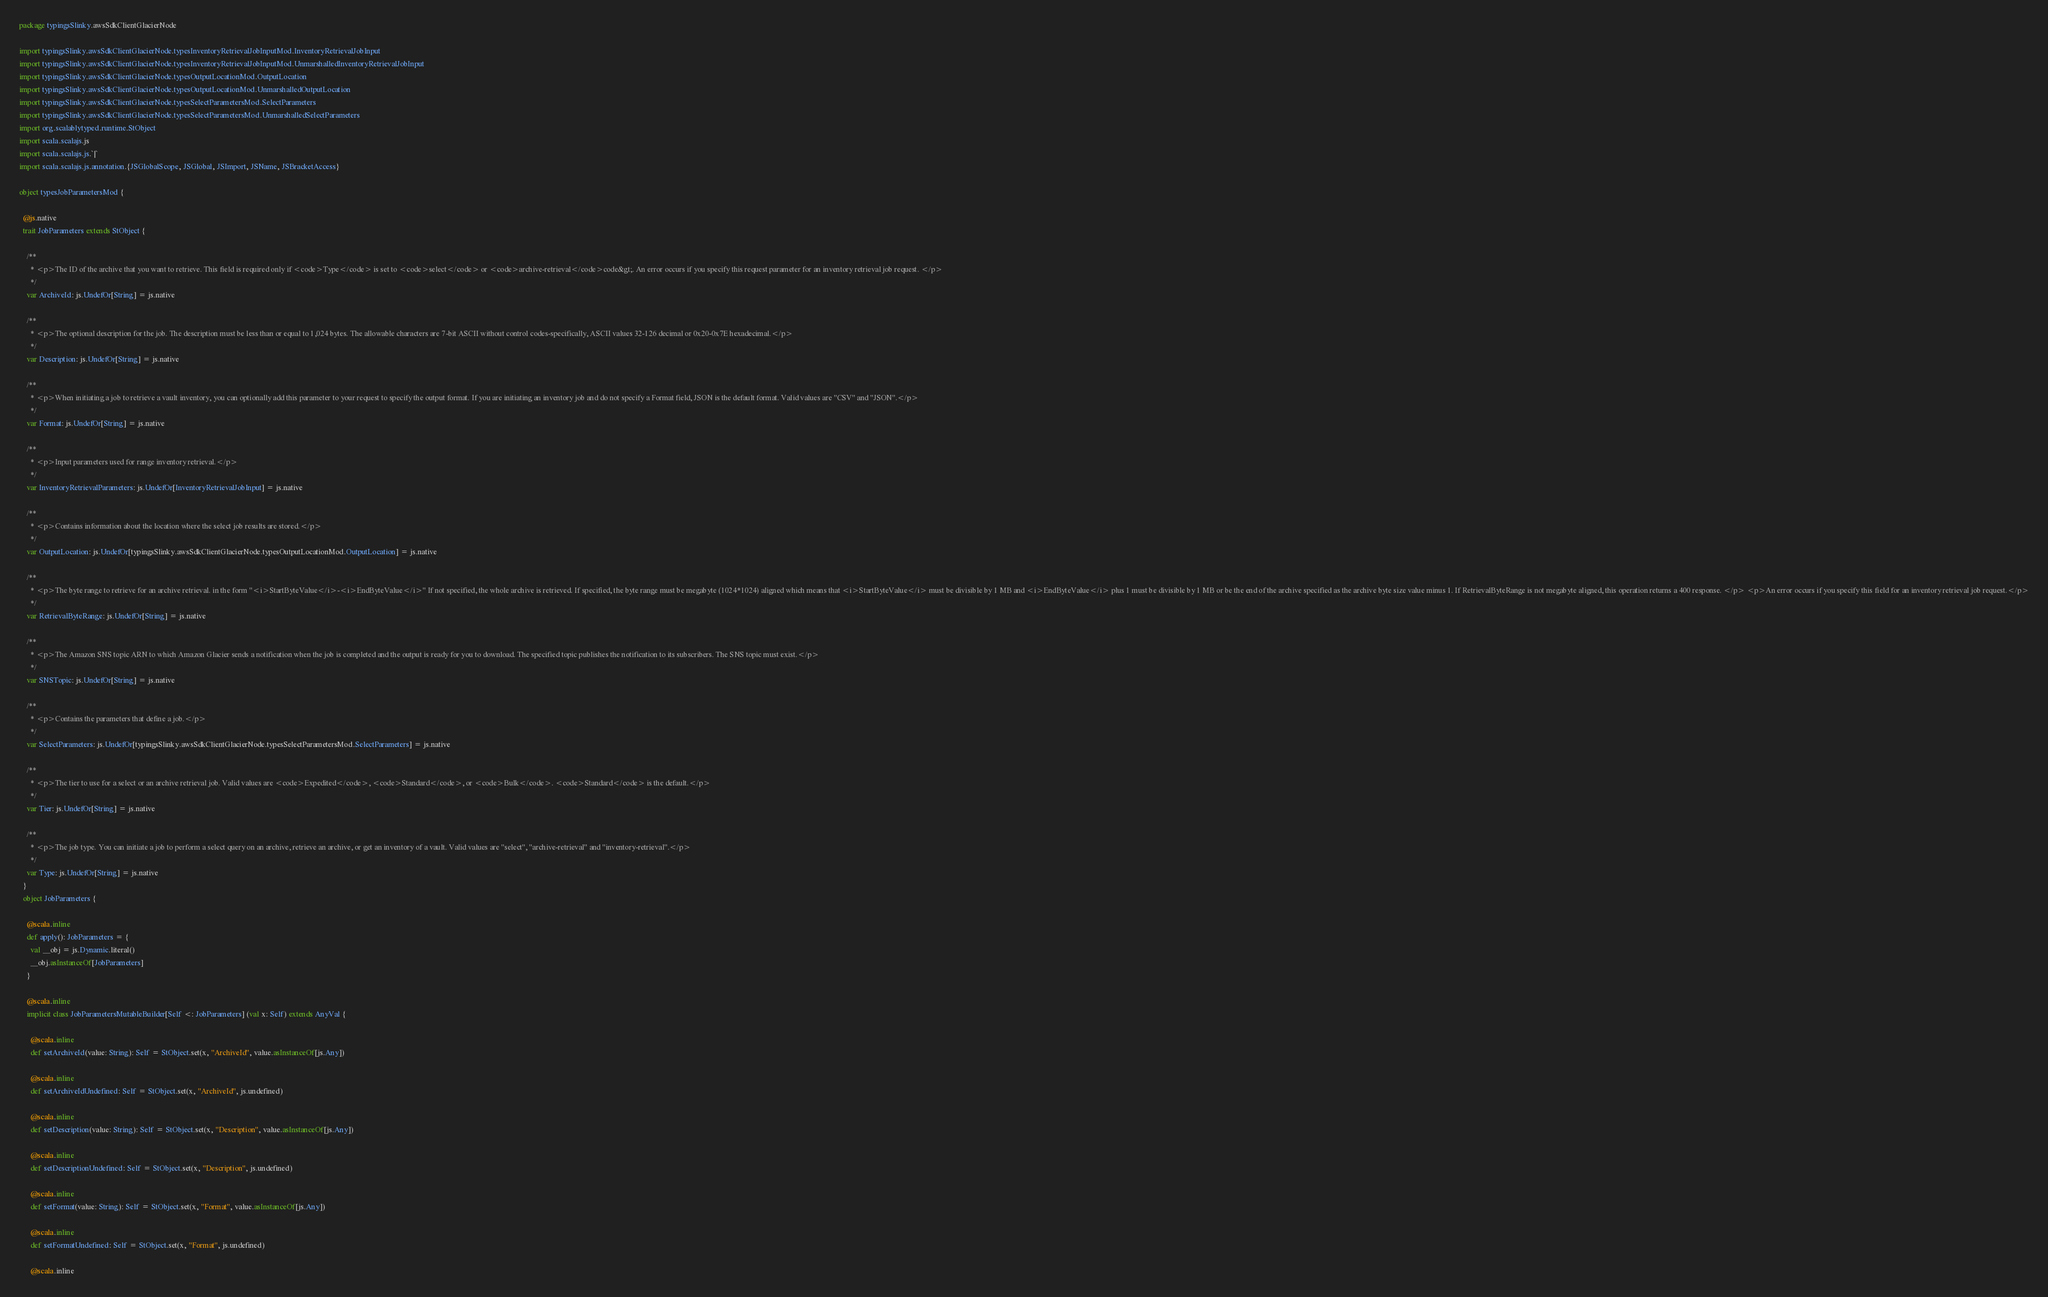<code> <loc_0><loc_0><loc_500><loc_500><_Scala_>package typingsSlinky.awsSdkClientGlacierNode

import typingsSlinky.awsSdkClientGlacierNode.typesInventoryRetrievalJobInputMod.InventoryRetrievalJobInput
import typingsSlinky.awsSdkClientGlacierNode.typesInventoryRetrievalJobInputMod.UnmarshalledInventoryRetrievalJobInput
import typingsSlinky.awsSdkClientGlacierNode.typesOutputLocationMod.OutputLocation
import typingsSlinky.awsSdkClientGlacierNode.typesOutputLocationMod.UnmarshalledOutputLocation
import typingsSlinky.awsSdkClientGlacierNode.typesSelectParametersMod.SelectParameters
import typingsSlinky.awsSdkClientGlacierNode.typesSelectParametersMod.UnmarshalledSelectParameters
import org.scalablytyped.runtime.StObject
import scala.scalajs.js
import scala.scalajs.js.`|`
import scala.scalajs.js.annotation.{JSGlobalScope, JSGlobal, JSImport, JSName, JSBracketAccess}

object typesJobParametersMod {
  
  @js.native
  trait JobParameters extends StObject {
    
    /**
      * <p>The ID of the archive that you want to retrieve. This field is required only if <code>Type</code> is set to <code>select</code> or <code>archive-retrieval</code>code&gt;. An error occurs if you specify this request parameter for an inventory retrieval job request. </p>
      */
    var ArchiveId: js.UndefOr[String] = js.native
    
    /**
      * <p>The optional description for the job. The description must be less than or equal to 1,024 bytes. The allowable characters are 7-bit ASCII without control codes-specifically, ASCII values 32-126 decimal or 0x20-0x7E hexadecimal.</p>
      */
    var Description: js.UndefOr[String] = js.native
    
    /**
      * <p>When initiating a job to retrieve a vault inventory, you can optionally add this parameter to your request to specify the output format. If you are initiating an inventory job and do not specify a Format field, JSON is the default format. Valid values are "CSV" and "JSON".</p>
      */
    var Format: js.UndefOr[String] = js.native
    
    /**
      * <p>Input parameters used for range inventory retrieval.</p>
      */
    var InventoryRetrievalParameters: js.UndefOr[InventoryRetrievalJobInput] = js.native
    
    /**
      * <p>Contains information about the location where the select job results are stored.</p>
      */
    var OutputLocation: js.UndefOr[typingsSlinky.awsSdkClientGlacierNode.typesOutputLocationMod.OutputLocation] = js.native
    
    /**
      * <p>The byte range to retrieve for an archive retrieval. in the form "<i>StartByteValue</i>-<i>EndByteValue</i>" If not specified, the whole archive is retrieved. If specified, the byte range must be megabyte (1024*1024) aligned which means that <i>StartByteValue</i> must be divisible by 1 MB and <i>EndByteValue</i> plus 1 must be divisible by 1 MB or be the end of the archive specified as the archive byte size value minus 1. If RetrievalByteRange is not megabyte aligned, this operation returns a 400 response. </p> <p>An error occurs if you specify this field for an inventory retrieval job request.</p>
      */
    var RetrievalByteRange: js.UndefOr[String] = js.native
    
    /**
      * <p>The Amazon SNS topic ARN to which Amazon Glacier sends a notification when the job is completed and the output is ready for you to download. The specified topic publishes the notification to its subscribers. The SNS topic must exist.</p>
      */
    var SNSTopic: js.UndefOr[String] = js.native
    
    /**
      * <p>Contains the parameters that define a job.</p>
      */
    var SelectParameters: js.UndefOr[typingsSlinky.awsSdkClientGlacierNode.typesSelectParametersMod.SelectParameters] = js.native
    
    /**
      * <p>The tier to use for a select or an archive retrieval job. Valid values are <code>Expedited</code>, <code>Standard</code>, or <code>Bulk</code>. <code>Standard</code> is the default.</p>
      */
    var Tier: js.UndefOr[String] = js.native
    
    /**
      * <p>The job type. You can initiate a job to perform a select query on an archive, retrieve an archive, or get an inventory of a vault. Valid values are "select", "archive-retrieval" and "inventory-retrieval".</p>
      */
    var Type: js.UndefOr[String] = js.native
  }
  object JobParameters {
    
    @scala.inline
    def apply(): JobParameters = {
      val __obj = js.Dynamic.literal()
      __obj.asInstanceOf[JobParameters]
    }
    
    @scala.inline
    implicit class JobParametersMutableBuilder[Self <: JobParameters] (val x: Self) extends AnyVal {
      
      @scala.inline
      def setArchiveId(value: String): Self = StObject.set(x, "ArchiveId", value.asInstanceOf[js.Any])
      
      @scala.inline
      def setArchiveIdUndefined: Self = StObject.set(x, "ArchiveId", js.undefined)
      
      @scala.inline
      def setDescription(value: String): Self = StObject.set(x, "Description", value.asInstanceOf[js.Any])
      
      @scala.inline
      def setDescriptionUndefined: Self = StObject.set(x, "Description", js.undefined)
      
      @scala.inline
      def setFormat(value: String): Self = StObject.set(x, "Format", value.asInstanceOf[js.Any])
      
      @scala.inline
      def setFormatUndefined: Self = StObject.set(x, "Format", js.undefined)
      
      @scala.inline</code> 